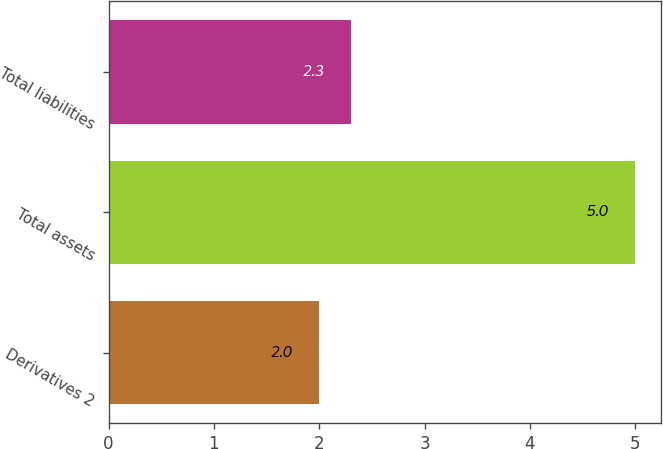<chart> <loc_0><loc_0><loc_500><loc_500><bar_chart><fcel>Derivatives 2<fcel>Total assets<fcel>Total liabilities<nl><fcel>2<fcel>5<fcel>2.3<nl></chart> 